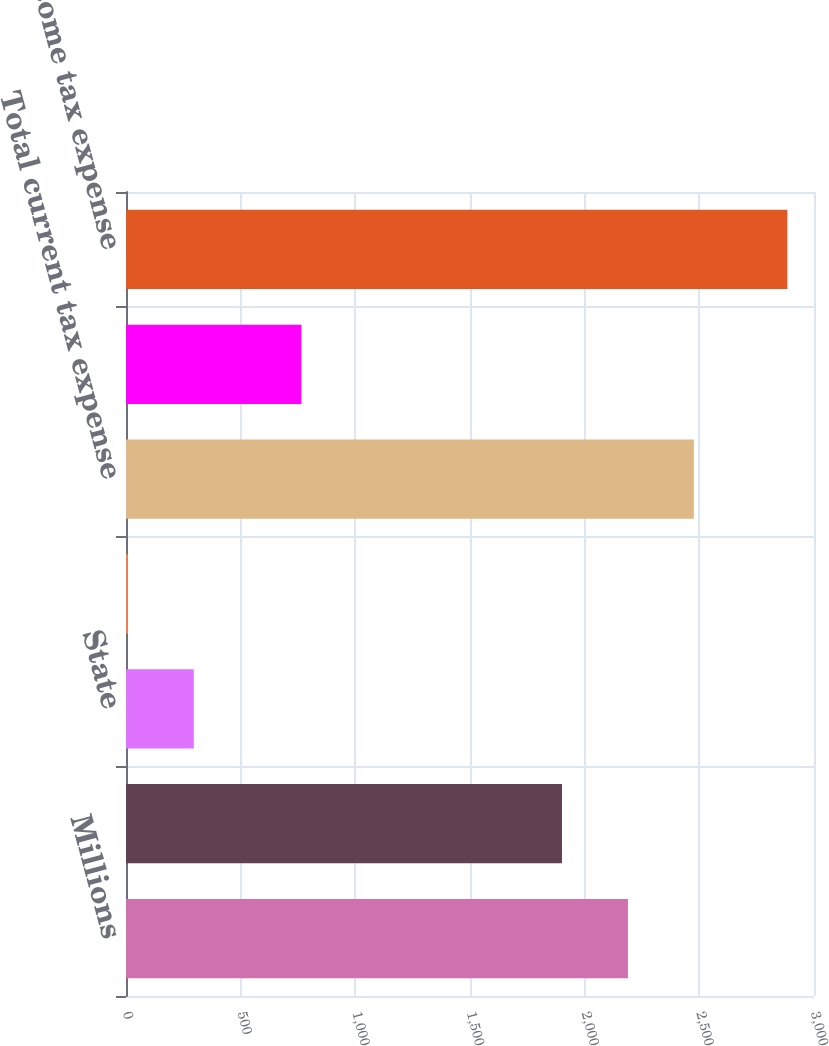<chart> <loc_0><loc_0><loc_500><loc_500><bar_chart><fcel>Millions<fcel>Federal<fcel>State<fcel>Foreign<fcel>Total current tax expense<fcel>Total deferred and other tax<fcel>Total income tax expense<nl><fcel>2188.6<fcel>1901<fcel>295.6<fcel>8<fcel>2476.2<fcel>765<fcel>2884<nl></chart> 